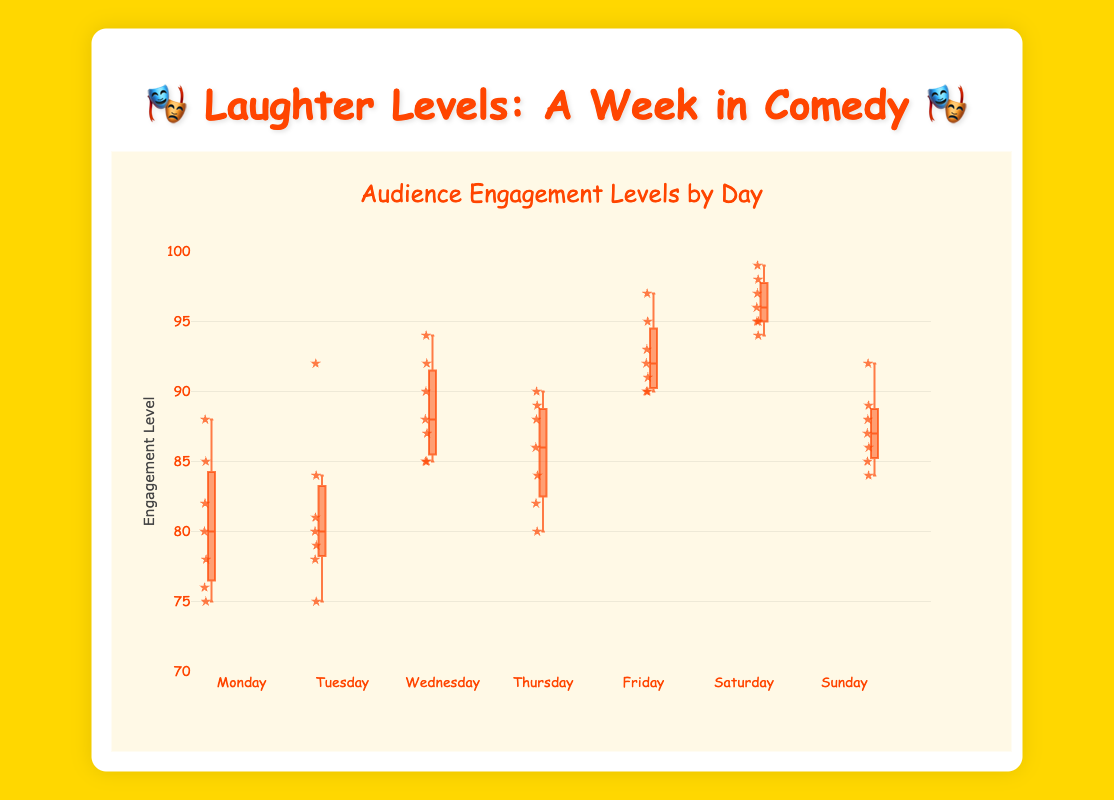What is the title of the figure? The title is located at the top of the figure and summarizes what the visual represents.
Answer: Audience Engagement Levels by Day Which day has the highest median engagement level? By observing the medians (the line inside each box), the highest median line corresponds to Saturday.
Answer: Saturday What is the range of engagement levels on Monday? The range in a box plot is between the smallest and largest data points, ignoring outliers. For Monday, the minimum is 75 and the maximum is 88.
Answer: 75-88 How does the interquartile range (IQR) of Wednesday compare to Tuesday? The IQR is the range between the first quartile (lower edge of the box) and the third quartile (upper edge of the box). Wednesday has a wider box, indicating a larger IQR compared to Tuesday.
Answer: Wednesday has a larger IQR than Tuesday Which day shows the most variability in engagement levels? Variability is often represented by the length of the box and the whiskers. The longest box and whiskers belong to Saturday, indicating it has the most variability.
Answer: Saturday What is the median engagement level on Friday? The median is the line inside the box. For Friday, it's around 92.
Answer: 92 Compare the engagement levels on Sunday and Wednesday, which day has higher third quartile value? The third quartile is the top edge of the box. Wednesday's top edge is higher than Sunday's.
Answer: Wednesday Are there any outliers in the data? Outliers in a box plot typically appear as individual points outside the whiskers. Here, there are no points shown outside the whiskers, indicating no outliers.
Answer: No What is the lowest engagement level recorded across all days? The lowest engagement level can be found by looking at the bottoms of all whiskers. The lowest point is 75, recorded on Monday.
Answer: 75 Which day has the smallest interquartile range (IQR)? The IQR is the box's width. The smallest box appears to be Tuesday's.
Answer: Tuesday 